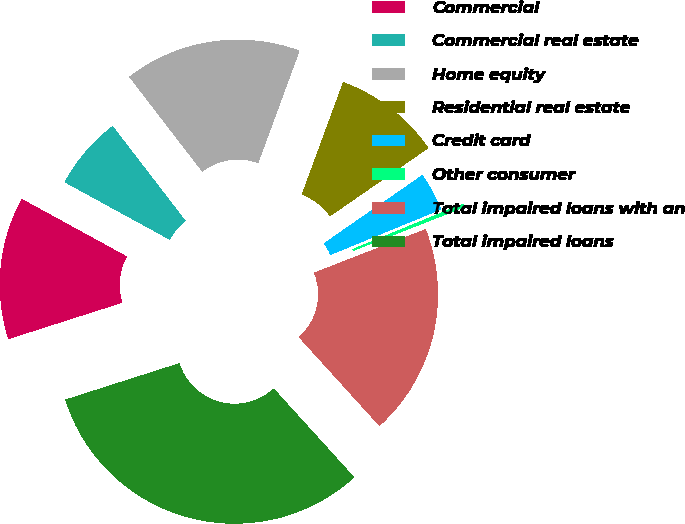Convert chart to OTSL. <chart><loc_0><loc_0><loc_500><loc_500><pie_chart><fcel>Commercial<fcel>Commercial real estate<fcel>Home equity<fcel>Residential real estate<fcel>Credit card<fcel>Other consumer<fcel>Total impaired loans with an<fcel>Total impaired loans<nl><fcel>12.89%<fcel>6.59%<fcel>16.05%<fcel>9.74%<fcel>3.44%<fcel>0.28%<fcel>19.2%<fcel>31.81%<nl></chart> 